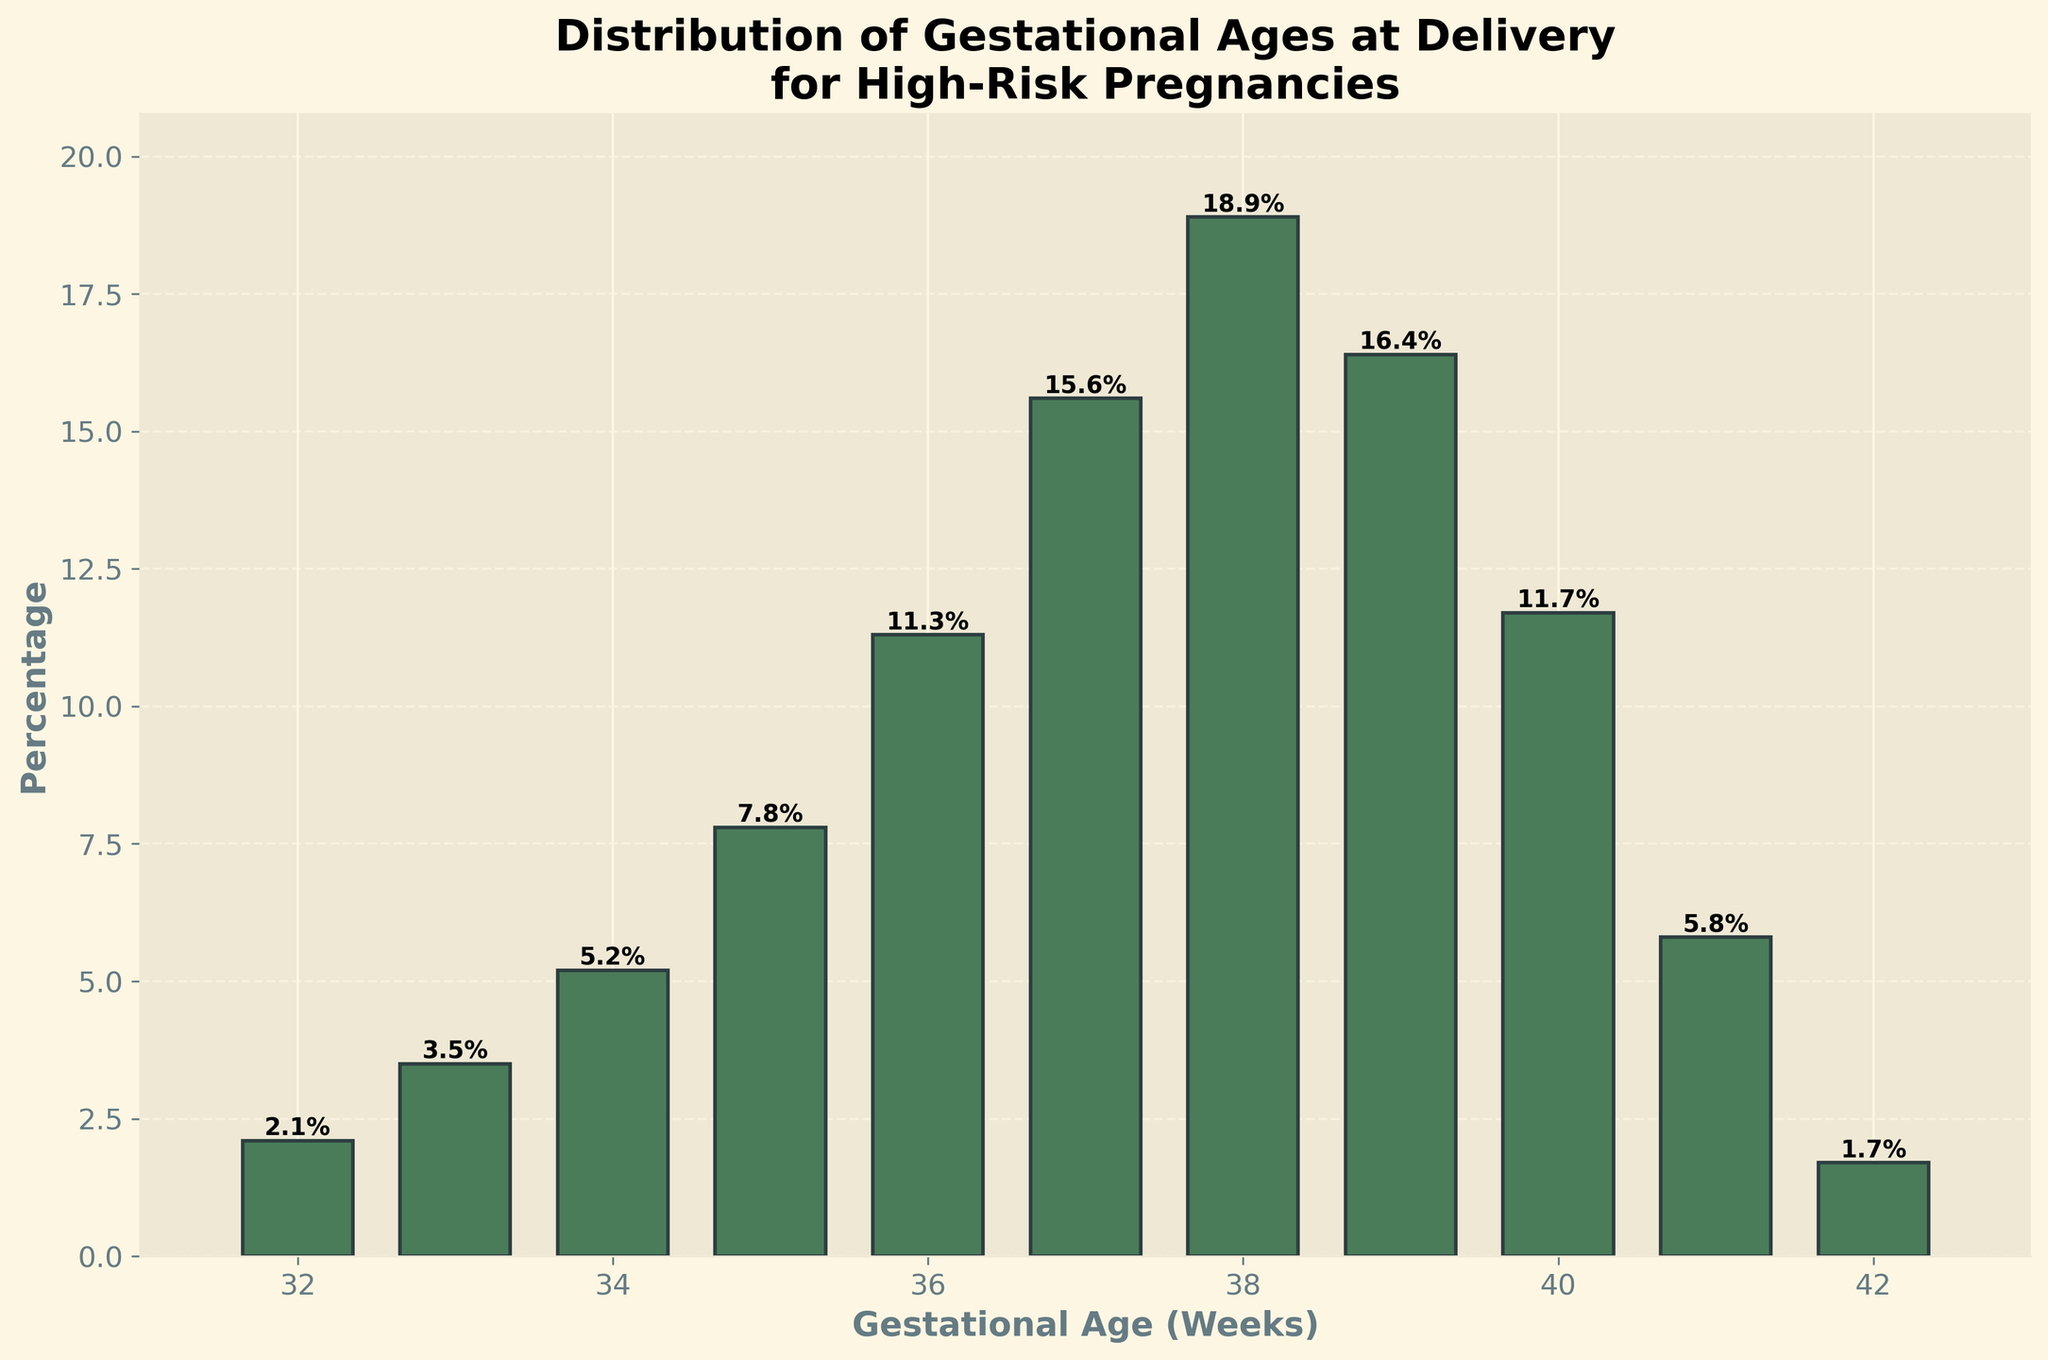What is the gestational age with the highest percentage of deliveries? Look at the bar with the greatest height, which represents the highest percentage. The bar at 38 weeks is the tallest.
Answer: 38 weeks What is the combined percentage of deliveries at 37 and 38 weeks? Sum the percentages for the bars corresponding to 37 and 38 weeks: 15.6% + 18.9% = 34.5%.
Answer: 34.5% Which gestational age has a higher percentage of deliveries, 35 weeks or 36 weeks? Compare the heights of the bars for 35 and 36 weeks. The bar for 36 weeks is taller, indicating a higher percentage.
Answer: 36 weeks How does the percentage of deliveries at 39 weeks compare to the percentage at 40 weeks? The bar for 39 weeks is slightly taller than the bar for 40 weeks. Compare the exact percentages: 16.4% (39 weeks) vs. 11.7% (40 weeks).
Answer: 39 weeks is higher What is the total percentage of deliveries that occur between 32 and 34 weeks (inclusive)? Sum the percentages for 32, 33, and 34 weeks: 2.1% + 3.5% + 5.2% = 10.8%.
Answer: 10.8% Which gestational age has a lower percentage of deliveries, 41 weeks or 42 weeks? Compare the heights of the bars for 41 and 42 weeks. The bar for 42 weeks is shorter, indicating a lower percentage.
Answer: 42 weeks How much higher is the percentage of deliveries at 38 weeks compared to the percentage at 33 weeks? Subtract the percentage for 33 weeks (3.5%) from the percentage for 38 weeks (18.9%): 18.9% - 3.5% = 15.4%.
Answer: 15.4% What is the percentage difference between the gestational age with the highest percentage and the gestational age with the lowest percentage? Identify the highest (38 weeks, 18.9%) and lowest (42 weeks, 1.7%) percentages, then subtract the lowest from the highest: 18.9% - 1.7% = 17.2%.
Answer: 17.2% How does the distribution of deliveries change from 36 weeks to 38 weeks? Observe the trend in the bar heights from 36 to 38 weeks. The percentages increase from 11.3% (36 weeks) to 15.6% (37 weeks) and then to 18.9% (38 weeks).
Answer: Increases Which weeks have a combined percentage closest to 50% when summed together? Check combinations of consecutive weeks. Summing the largest percentages: 37 weeks (15.6%) + 38 weeks (18.9%) + 39 weeks (16.4%) = 50.9%, which is closest to 50%.
Answer: 37, 38, 39 weeks 